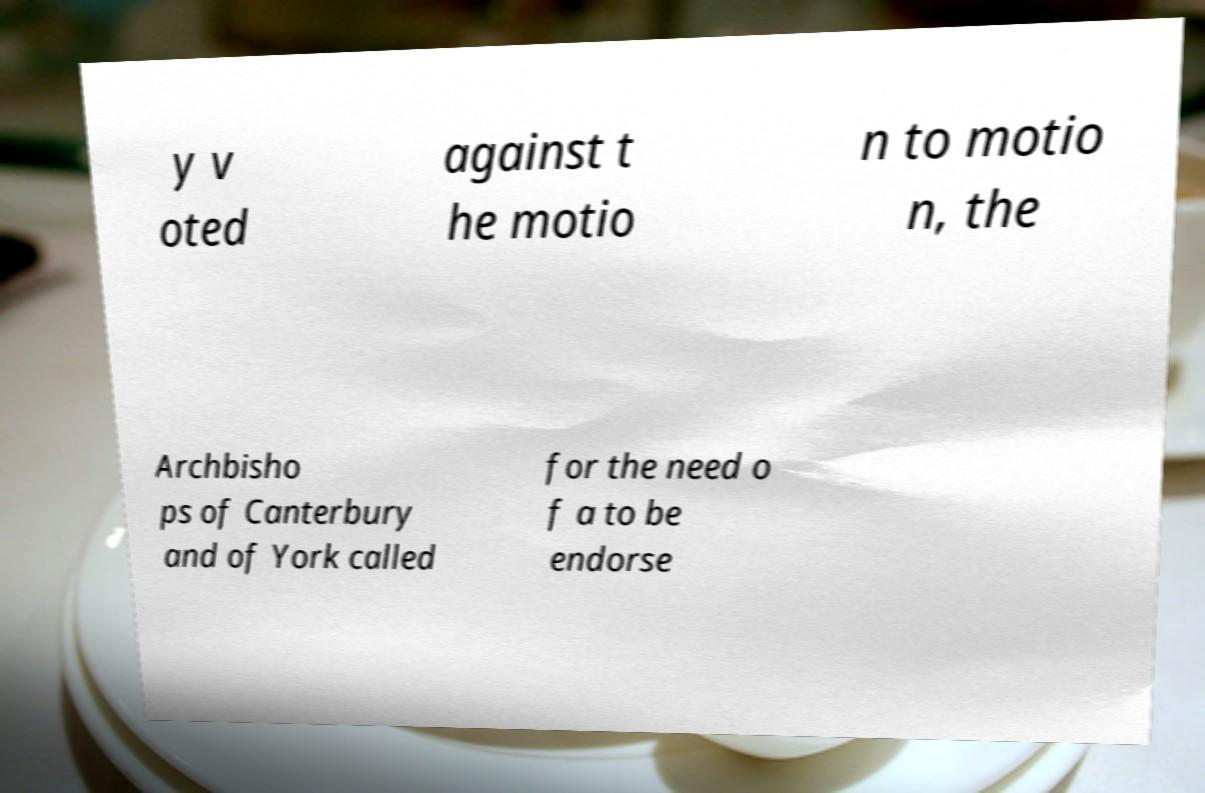Could you extract and type out the text from this image? y v oted against t he motio n to motio n, the Archbisho ps of Canterbury and of York called for the need o f a to be endorse 